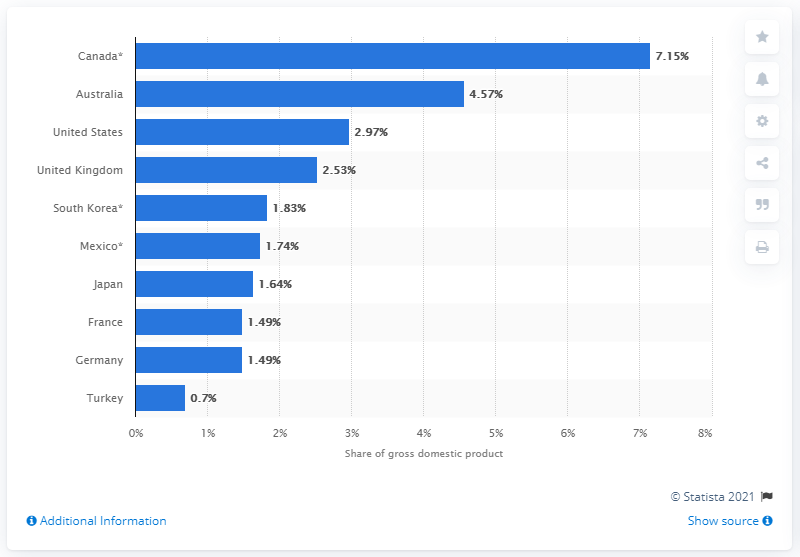Give some essential details in this illustration. The energy share of Germany's GDP was 1.49. In 2015, Canada's energy-related industry had a share of 7.15% of its Gross Domestic Product (GDP). 